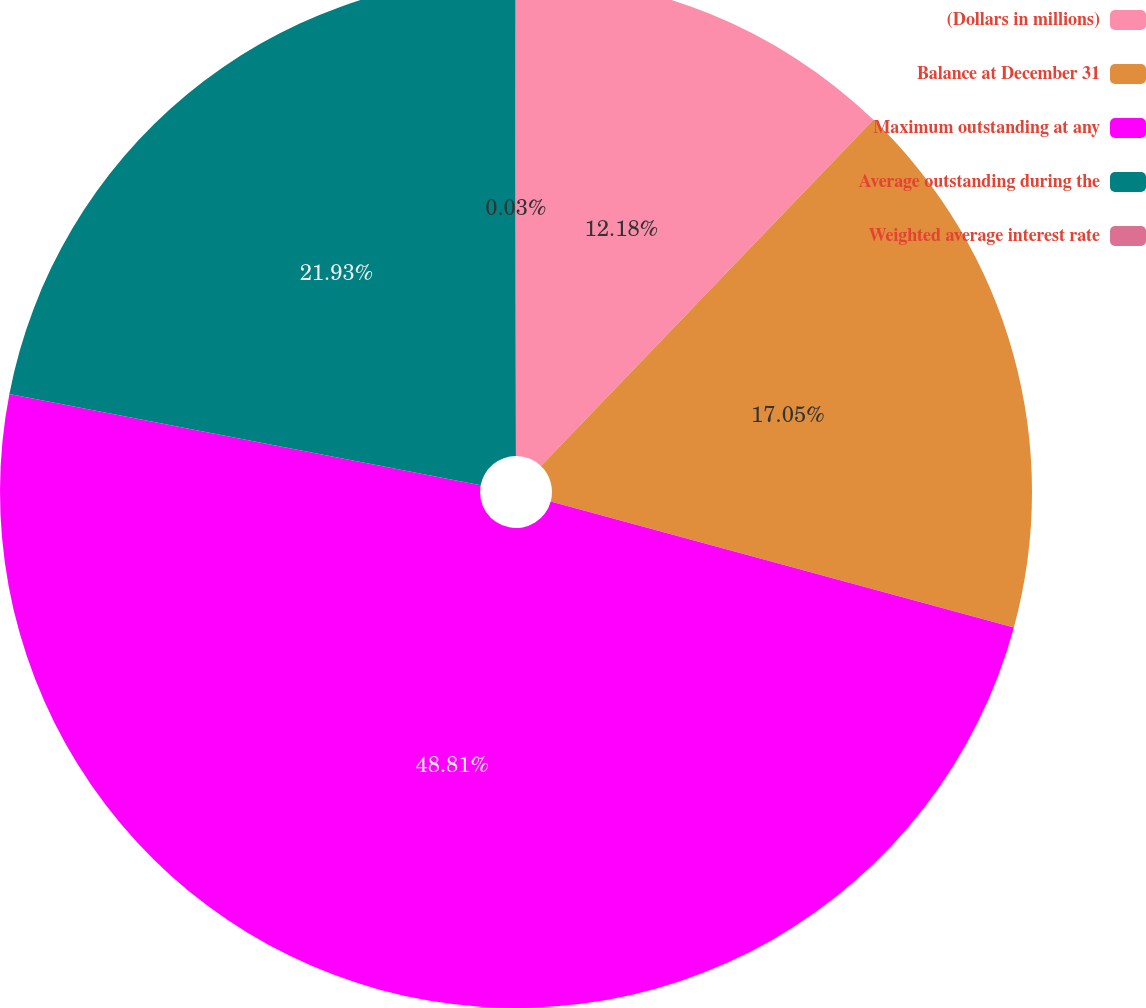Convert chart. <chart><loc_0><loc_0><loc_500><loc_500><pie_chart><fcel>(Dollars in millions)<fcel>Balance at December 31<fcel>Maximum outstanding at any<fcel>Average outstanding during the<fcel>Weighted average interest rate<nl><fcel>12.18%<fcel>17.05%<fcel>48.81%<fcel>21.93%<fcel>0.03%<nl></chart> 